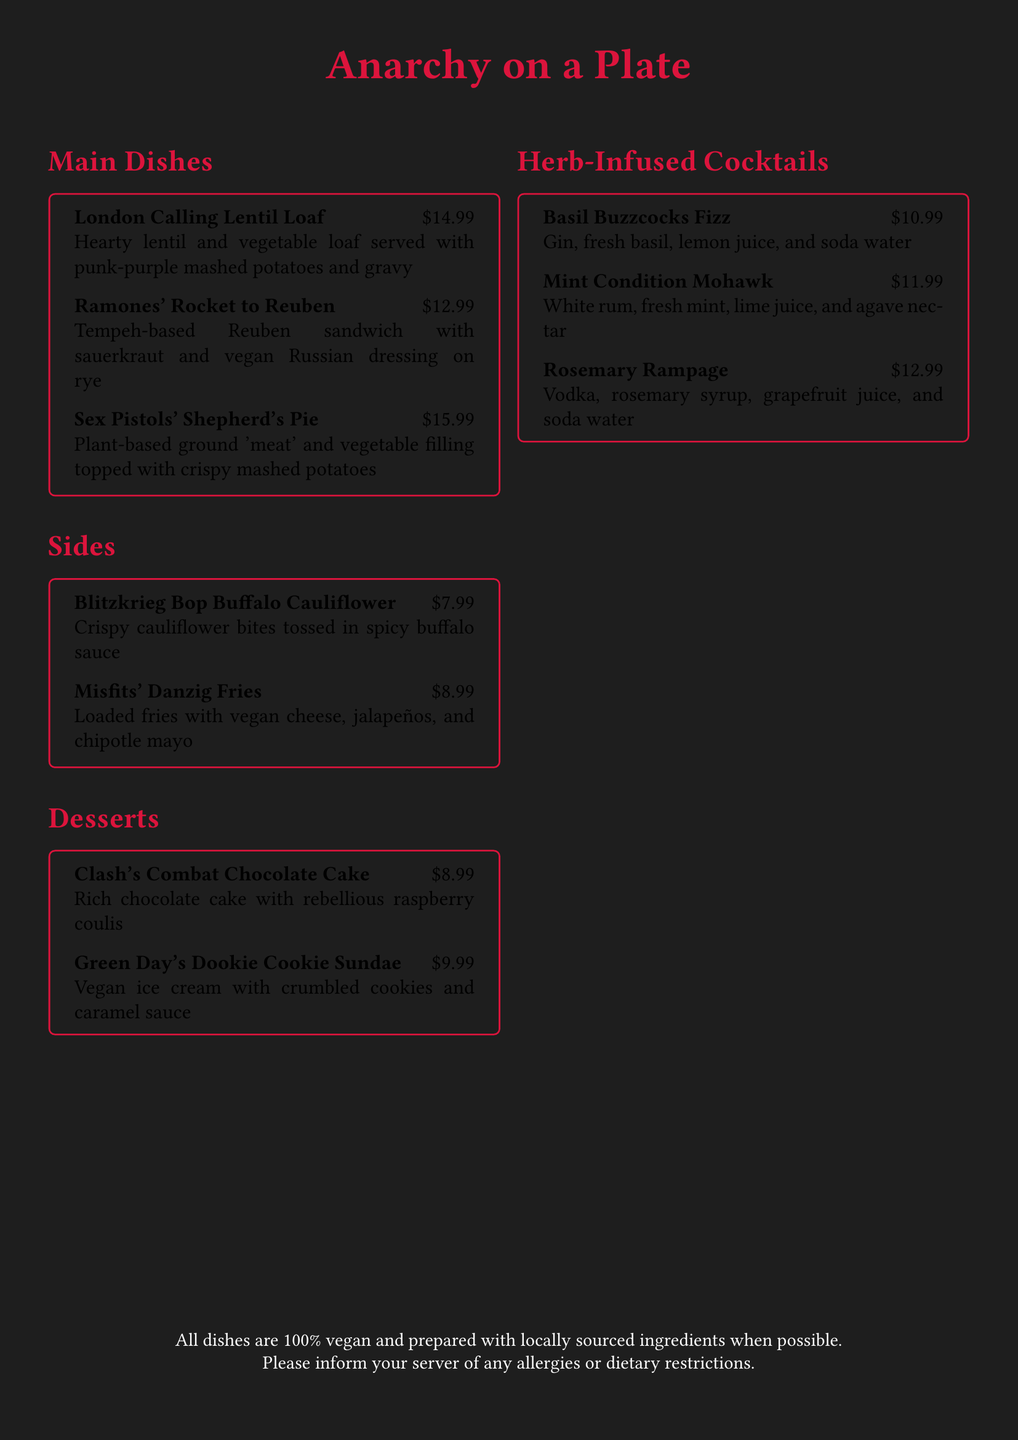What is the price of the London Calling Lentil Loaf? The price of London Calling Lentil Loaf is listed in the document as $14.99.
Answer: $14.99 What ingredients are in the Mint Condition Mohawk? The ingredients for the Mint Condition Mohawk cocktail include white rum, fresh mint, lime juice, and agave nectar.
Answer: White rum, fresh mint, lime juice, and agave nectar How many main dishes are listed in the menu? The document lists three main dishes in the "Main Dishes" section.
Answer: 3 What dessert features raspberry coulis? The dessert that features raspberry coulis is Clash's Combat Chocolate Cake.
Answer: Clash's Combat Chocolate Cake Which side dish is described as loaded fries? The loaded fries side dish is called Misfits' Danzig Fries.
Answer: Misfits' Danzig Fries What is the highest priced cocktail on the menu? The highest priced cocktail is Rosemary Rampage, priced at $12.99.
Answer: Rosemary Rampage Which dish is inspired by the Sex Pistols? The dish inspired by the Sex Pistols is the Shepherd's Pie.
Answer: Shepherd's Pie What type of cuisine is the menu focused on? The menu focuses on vegan cuisine.
Answer: vegan 